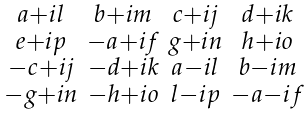<formula> <loc_0><loc_0><loc_500><loc_500>\begin{smallmatrix} a + i l & b + i m & c + i j & d + i k \\ e + i p & - a + i f & g + i n & h + i o \\ - c + i j & - d + i k & a - i l & b - i m \\ - g + i n & - h + i o & l - i p & - a - i f \end{smallmatrix}</formula> 